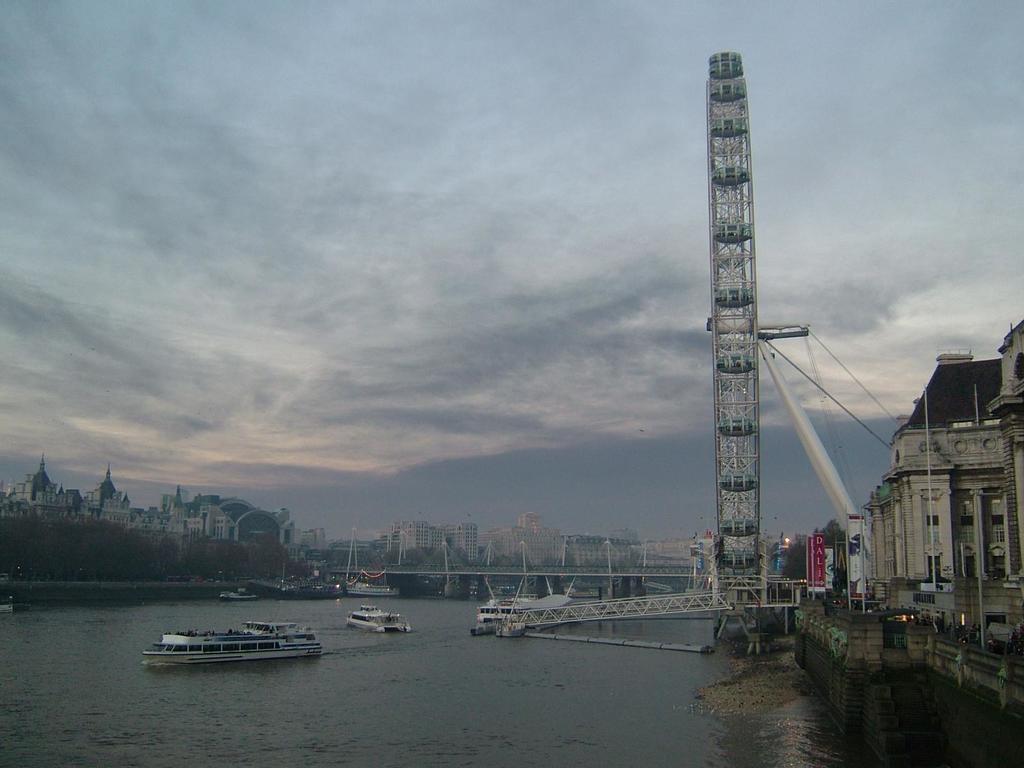Please provide a concise description of this image. On the right side of the picture there are buildings, boards, poles, people and other objects. In the center of the picture there is a water body and there are ships, bridge, poles and a tower. In the background there are buildings, trees and other objects. 